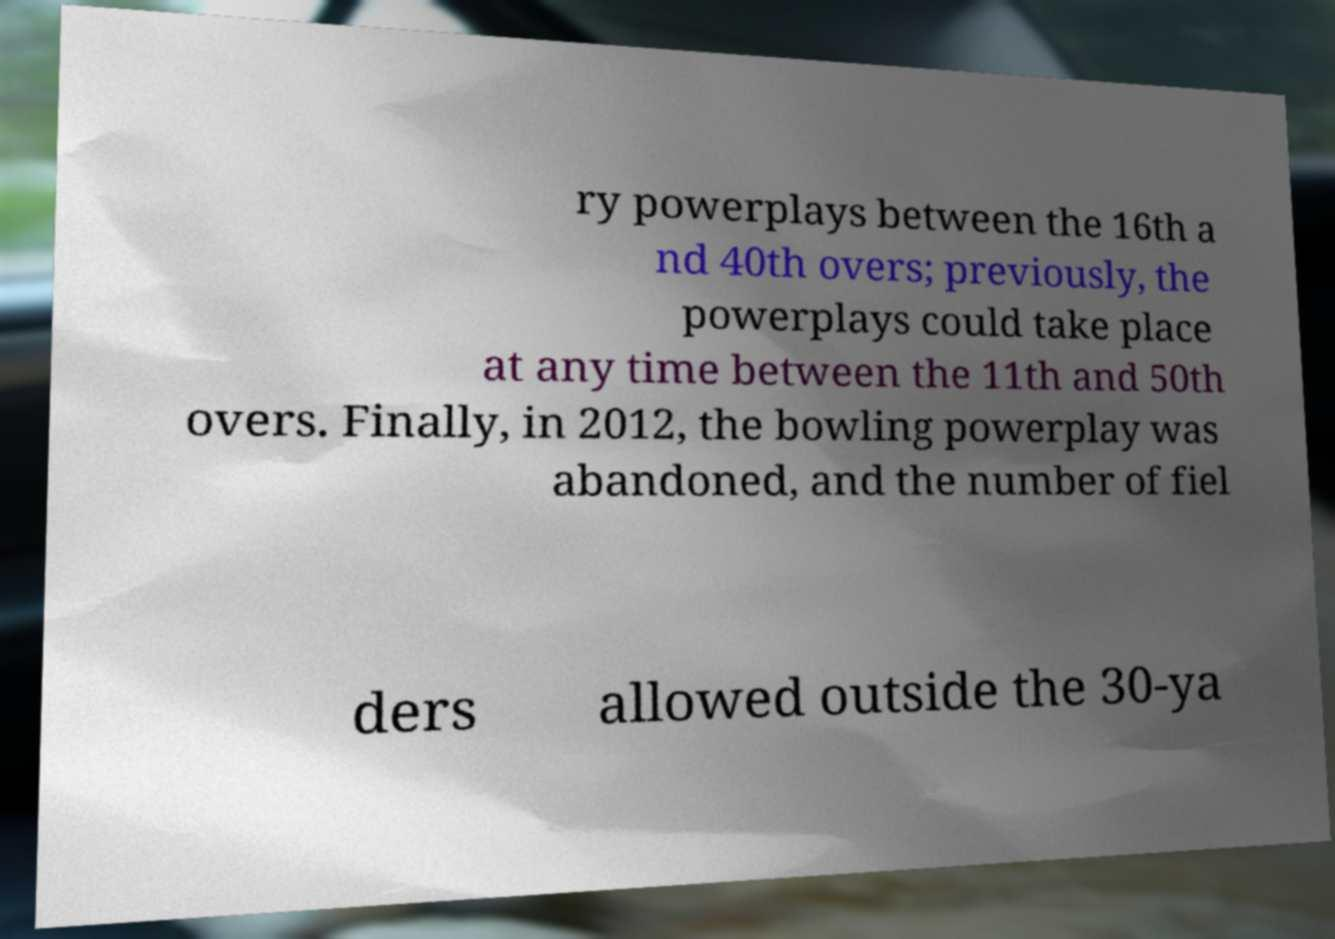There's text embedded in this image that I need extracted. Can you transcribe it verbatim? ry powerplays between the 16th a nd 40th overs; previously, the powerplays could take place at any time between the 11th and 50th overs. Finally, in 2012, the bowling powerplay was abandoned, and the number of fiel ders allowed outside the 30-ya 